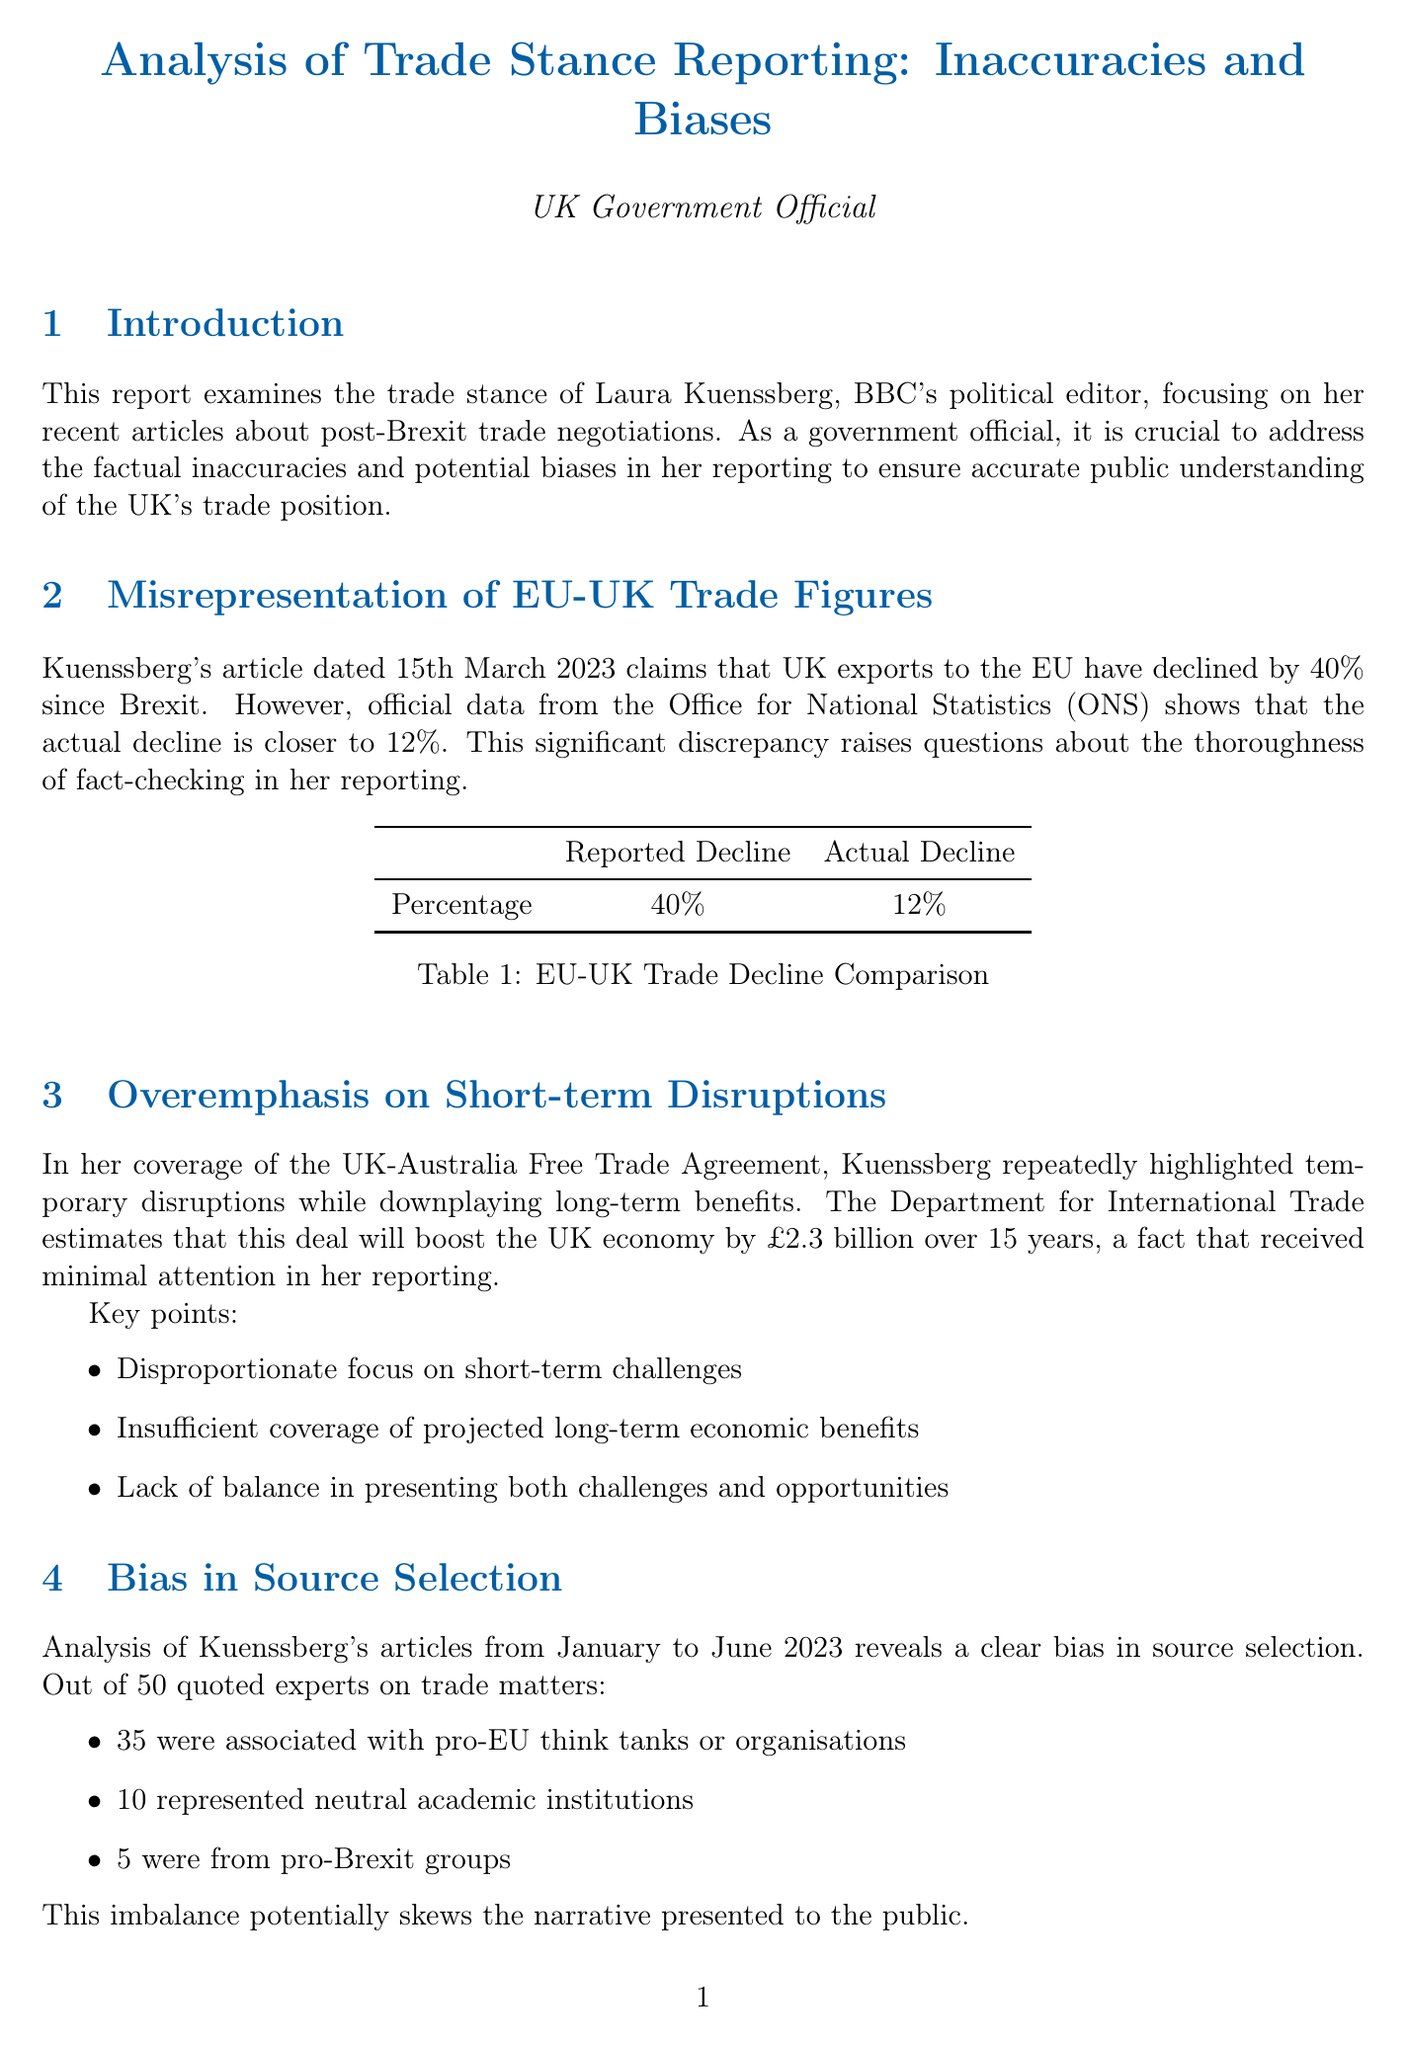What is the title of the report? The title of the report is explicitly stated at the top of the document, which provides the central theme of the analysis.
Answer: Analysis of Trade Stance Reporting: Inaccuracies and Biases Who is the political editor being examined in the report? The document clearly identifies the individual whose reporting is under scrutiny, as their name is mentioned in the introduction.
Answer: Laura Kuenssberg What percentage decline in UK exports to the EU did Kuenssberg report? The specific figure presented by Kuenssberg is highlighted in the corresponding section discussing trade figures, indicating a substantial reported decline.
Answer: 40% What is the actual percentage decline in UK exports to the EU according to the ONS? The document contrasts the reported figure with the actual statistic retrieved from a credible source, emphasizing the discrepancy between them.
Answer: 12% What is the estimated economic boost from the UK-Australia Free Trade Agreement over 15 years? This estimate is provided in the section detailing the long-term benefits of the trade agreement, illustrating its projected impact on the economy.
Answer: £2.3 billion How many pro-EU experts were quoted in Kuenssberg's reporting? The breakdown of quoted experts is mentioned in the document, which provides insight into the source selection bias present in her articles.
Answer: 35 What date was the article that misinterpreted WTO rules published? The report includes specific dates for articles discussed, including this particular instance concerning WTO rule interpretation.
Answer: 5th April 2023 Which trade initiative was neglected in Kuenssberg's coverage? The document lists specific topics that received minimal attention in her reporting, reflecting an oversight that could impact public understanding of trade opportunities.
Answer: CPTPP membership application What is one recommendation made in the report? The conclusion section outlines actionable steps that the government intends to take in response to the inaccuracies and biases found in the reporting, offering a way forward.
Answer: Issue formal corrections for factual inaccuracies through official government channels 